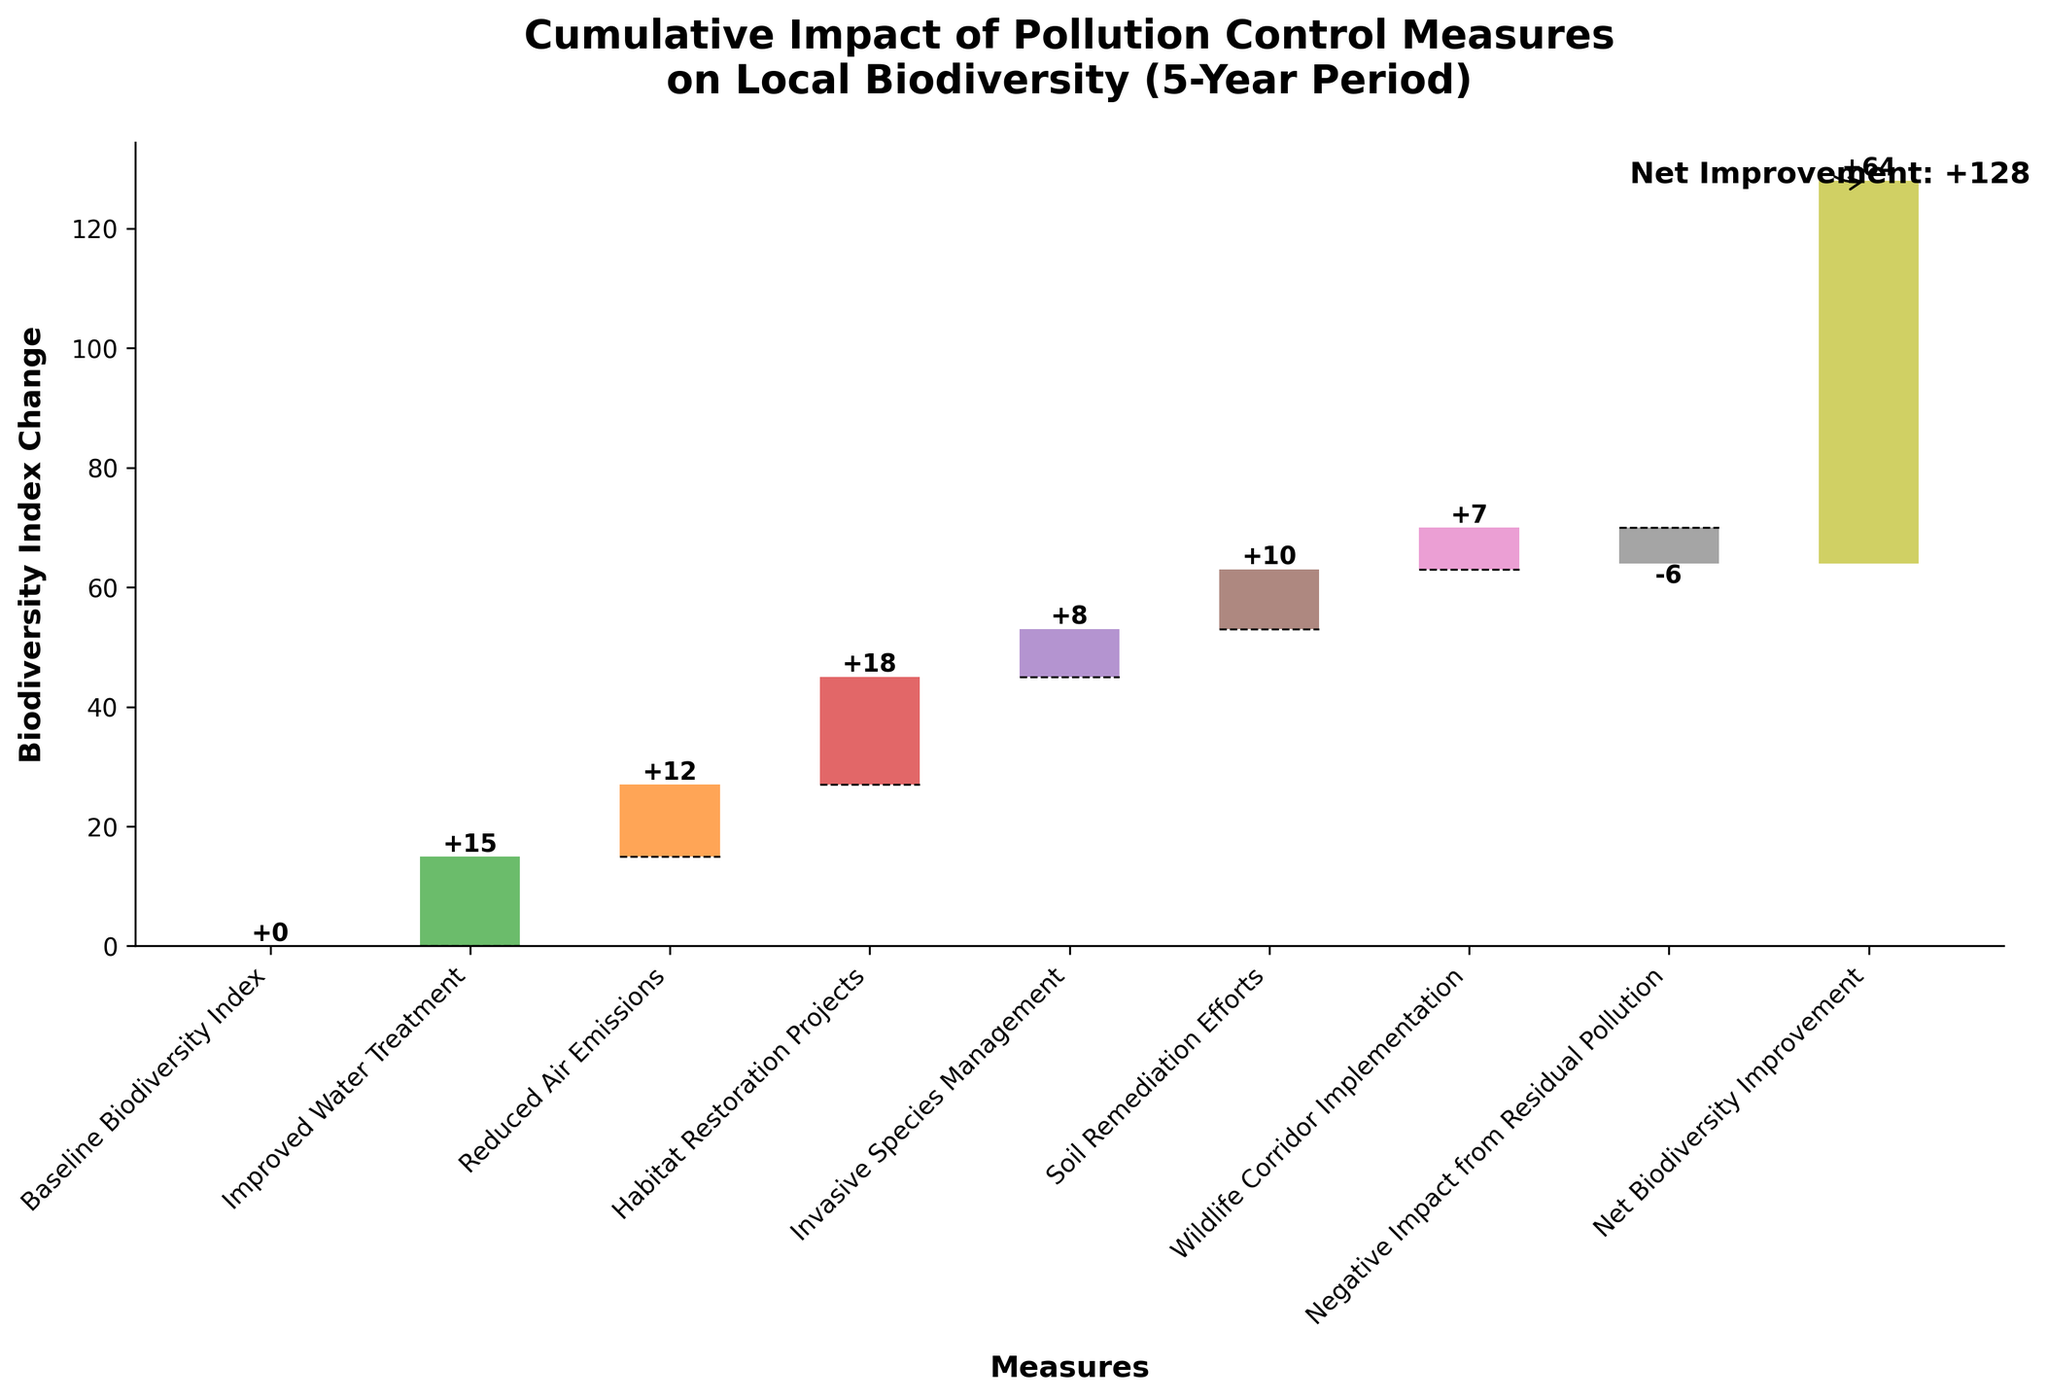What is the title of the figure? The title is usually located at the top of the figure, in a bigger and bold font. In this case, it reads "Cumulative Impact of Pollution Control Measures on Local Biodiversity (5-Year Period)".
Answer: Cumulative Impact of Pollution Control Measures on Local Biodiversity (5-Year Period) What is the range of the y-axis? By looking at the y-axis on the left of the figure, we can see it goes from -10 to 80.
Answer: -10 to 80 What measure provides the largest positive impact on the biodiversity index? By examining the height of each positive bar, "Habitat Restoration Projects" has the tallest bar with an increase of +18.
Answer: Habitat Restoration Projects What is the total positive impact from all measures combined, excluding the net improvement? We need to sum the positive impacts: 15 (Improved Water Treatment) + 12 (Reduced Air Emissions) + 18 (Habitat Restoration Projects) + 8 (Invasive Species Management) + 10 (Soil Remediation Efforts) + 7 (Wildlife Corridor Implementation) = 70.
Answer: 70 How does the impact of "Reduced Air Emissions" compare to "Soil Remediation Efforts"? "Reduced Air Emissions" provides a +12 impact, while "Soil Remediation Efforts" provides a +10 impact. Since 12 is greater than 10, "Reduced Air Emissions" has a larger impact.
Answer: Reduced Air Emissions has a larger impact Which measures contribute negatively to the biodiversity index? By identifying negative bars, "Negative Impact from Residual Pollution" is the only one with a negative value of -6.
Answer: Negative Impact from Residual Pollution What is the cumulative impact on biodiversity after all measures excluding residual pollution? Sum the positive impacts: 15 + 12 + 18 + 8 + 10 + 7 = 70. Without the negative impact of -6, the cumulative positive is 70.
Answer: 70 What is the net biodiversity improvement after 5 years? The figure's annotation and final bar indicate the net improvement is +64, which is also stated directly on the bar.
Answer: +64 If "Negative Impact from Residual Pollution" did not exist, what would be the net improvement? Starting from the total positive impact of 70 and adding it to the Baseline of 0 would make the impact 70. Without the negative impact, it would stay at 70.
Answer: 70 How much does "Habitat Restoration Projects" contribute to the net improvement? The bar for "Habitat Restoration Projects" is labeled as +18. Therefore, it contributes +18 to the net improvement.
Answer: +18 